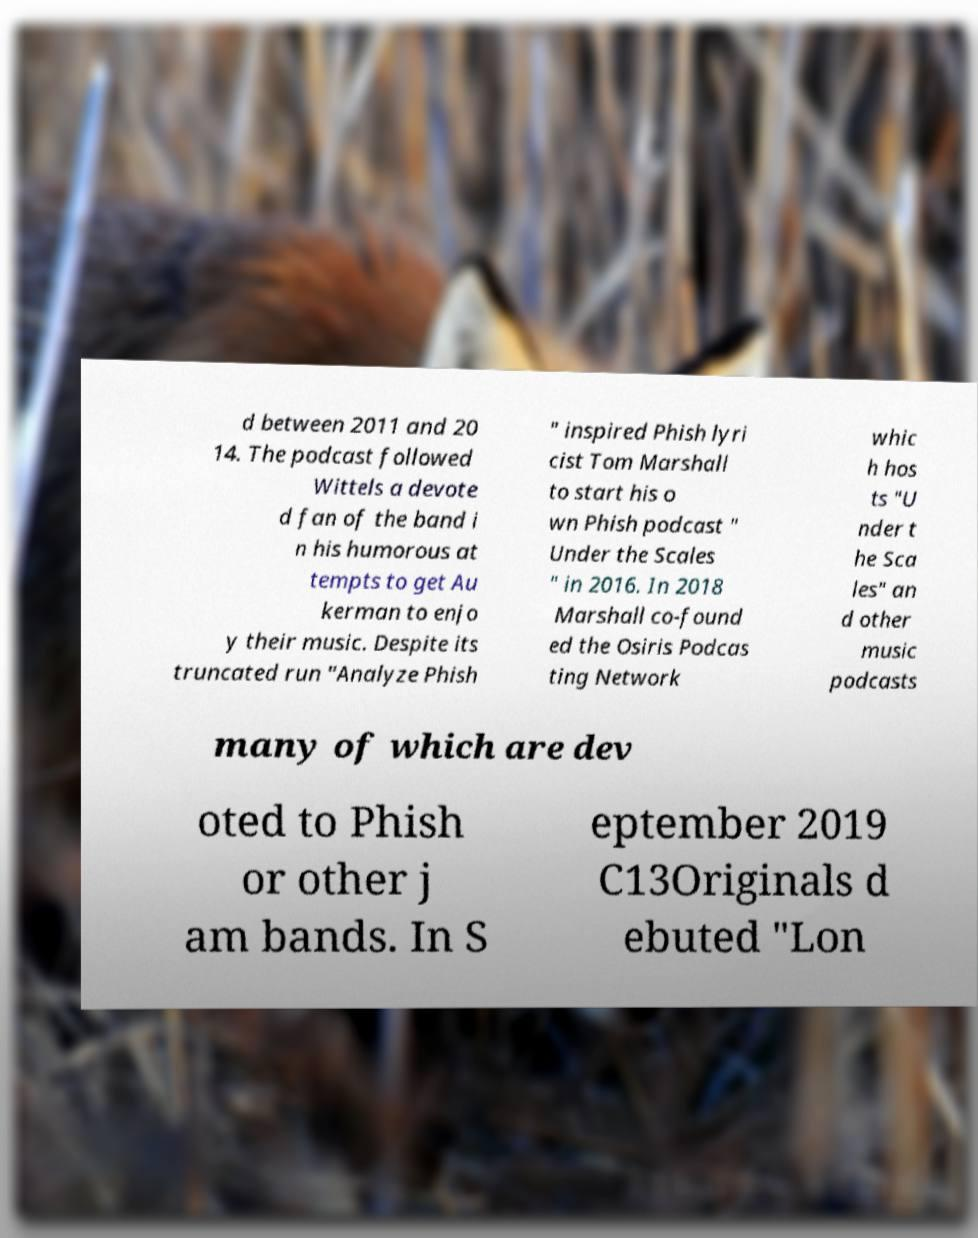Can you read and provide the text displayed in the image?This photo seems to have some interesting text. Can you extract and type it out for me? d between 2011 and 20 14. The podcast followed Wittels a devote d fan of the band i n his humorous at tempts to get Au kerman to enjo y their music. Despite its truncated run "Analyze Phish " inspired Phish lyri cist Tom Marshall to start his o wn Phish podcast " Under the Scales " in 2016. In 2018 Marshall co-found ed the Osiris Podcas ting Network whic h hos ts "U nder t he Sca les" an d other music podcasts many of which are dev oted to Phish or other j am bands. In S eptember 2019 C13Originals d ebuted "Lon 